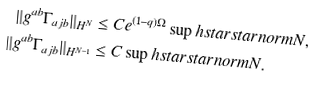Convert formula to latex. <formula><loc_0><loc_0><loc_500><loc_500>\| g ^ { a b } \Gamma _ { a j b } \| _ { H ^ { N } } & \leq C e ^ { ( 1 - q ) \Omega } \sup h s t a r s t a r n o r m { N } , \\ \| g ^ { a b } \Gamma _ { a j b } \| _ { H ^ { N - 1 } } & \leq C \sup h s t a r s t a r n o r m { N } .</formula> 